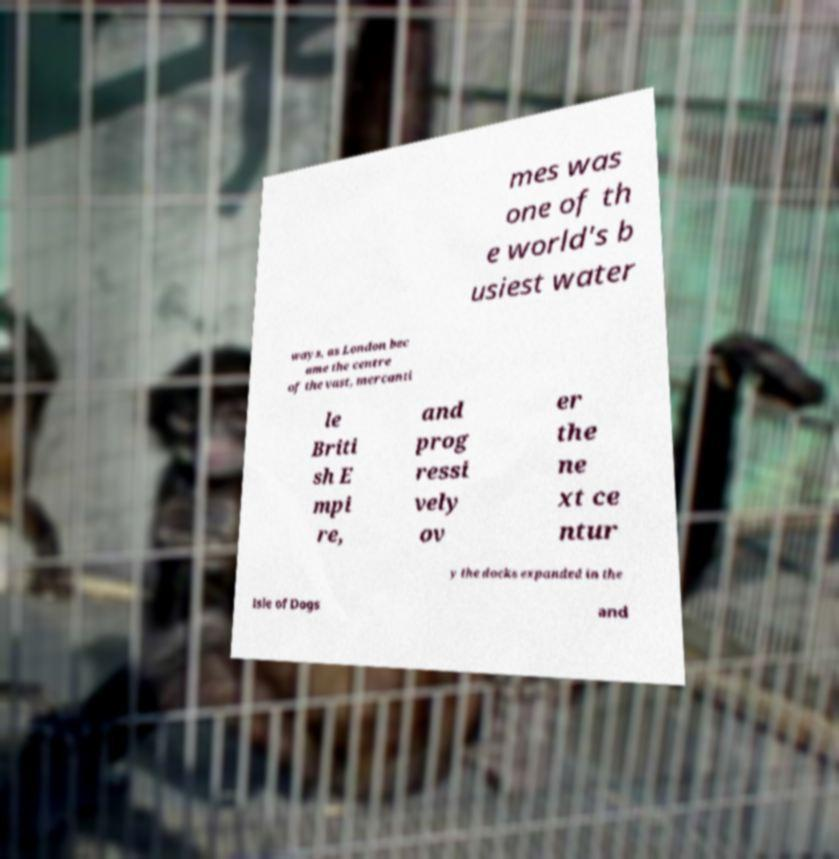Can you read and provide the text displayed in the image?This photo seems to have some interesting text. Can you extract and type it out for me? mes was one of th e world's b usiest water ways, as London bec ame the centre of the vast, mercanti le Briti sh E mpi re, and prog ressi vely ov er the ne xt ce ntur y the docks expanded in the Isle of Dogs and 